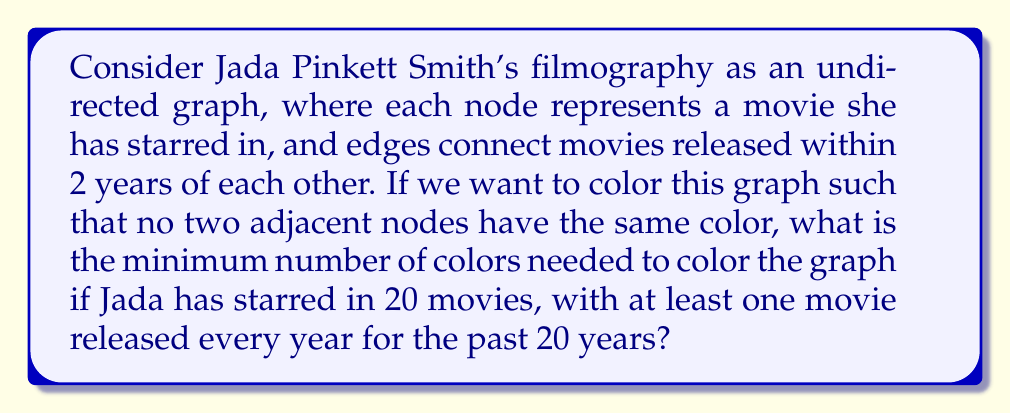Help me with this question. Let's approach this step-by-step:

1) First, we need to understand what the graph represents:
   - Each node is a movie Jada Pinkett Smith has starred in
   - There are 20 nodes in total
   - Edges connect movies released within 2 years of each other

2) Given that Jada has released at least one movie every year for the past 20 years, we can deduce that each movie is connected to at least two other movies (the ones released in the year before and after), and possibly up to four other movies (if there were movies released 2 years before and 2 years after).

3) This creates a graph with high connectivity, similar to a path graph but with additional edges.

4) In graph theory, the chromatic number (minimum number of colors needed) is always less than or equal to the maximum degree of the graph plus one. The maximum degree is the highest number of edges connected to any single node.

5) In this case, the maximum degree could be up to 4 (connecting to movies 2 years before, 1 year before, 1 year after, and 2 years after).

6) Therefore, by the theorem mentioned in step 4, we can say that the chromatic number is at most 5 (4 + 1).

7) However, we can actually color this graph with just 3 colors. Here's how:
   - Assign color 1 to movies released in years 1, 4, 7, 10, 13, 16, 19
   - Assign color 2 to movies released in years 2, 5, 8, 11, 14, 17, 20
   - Assign color 3 to movies released in years 3, 6, 9, 12, 15, 18

8) This coloring ensures that no two movies released within 2 years of each other have the same color.

Therefore, the minimum number of colors needed is 3.
Answer: 3 colors 